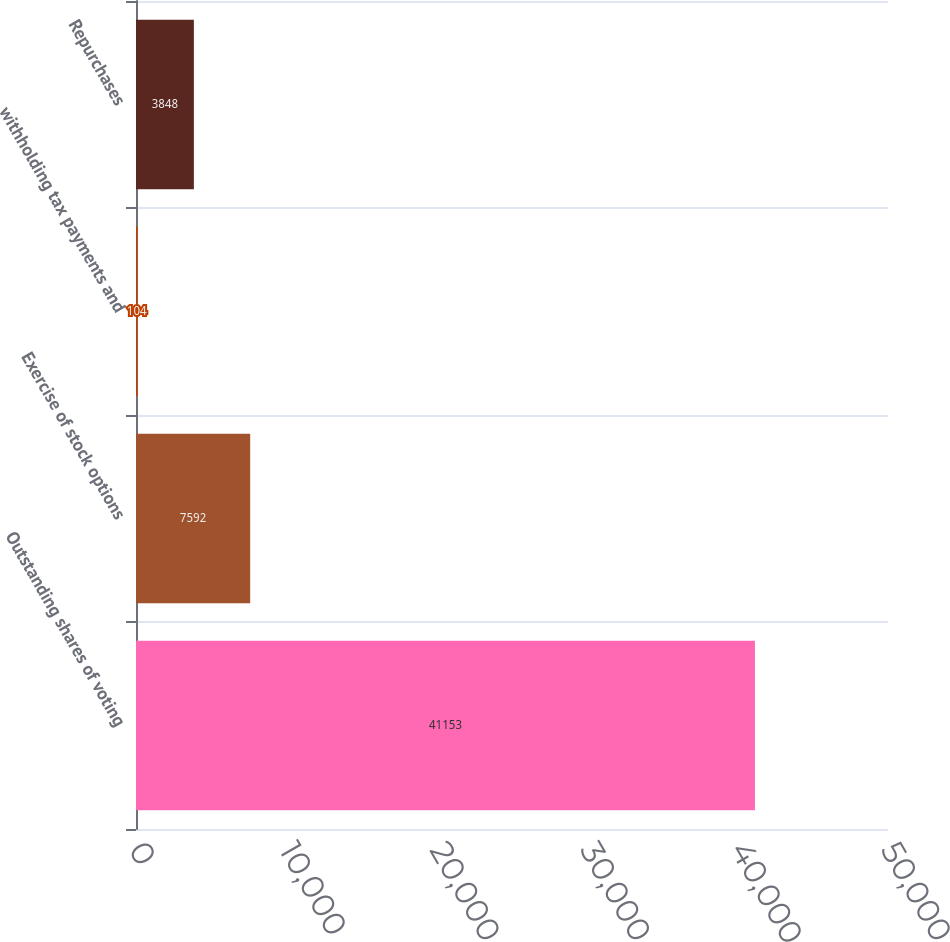Convert chart. <chart><loc_0><loc_0><loc_500><loc_500><bar_chart><fcel>Outstanding shares of voting<fcel>Exercise of stock options<fcel>withholding tax payments and<fcel>Repurchases<nl><fcel>41153<fcel>7592<fcel>104<fcel>3848<nl></chart> 